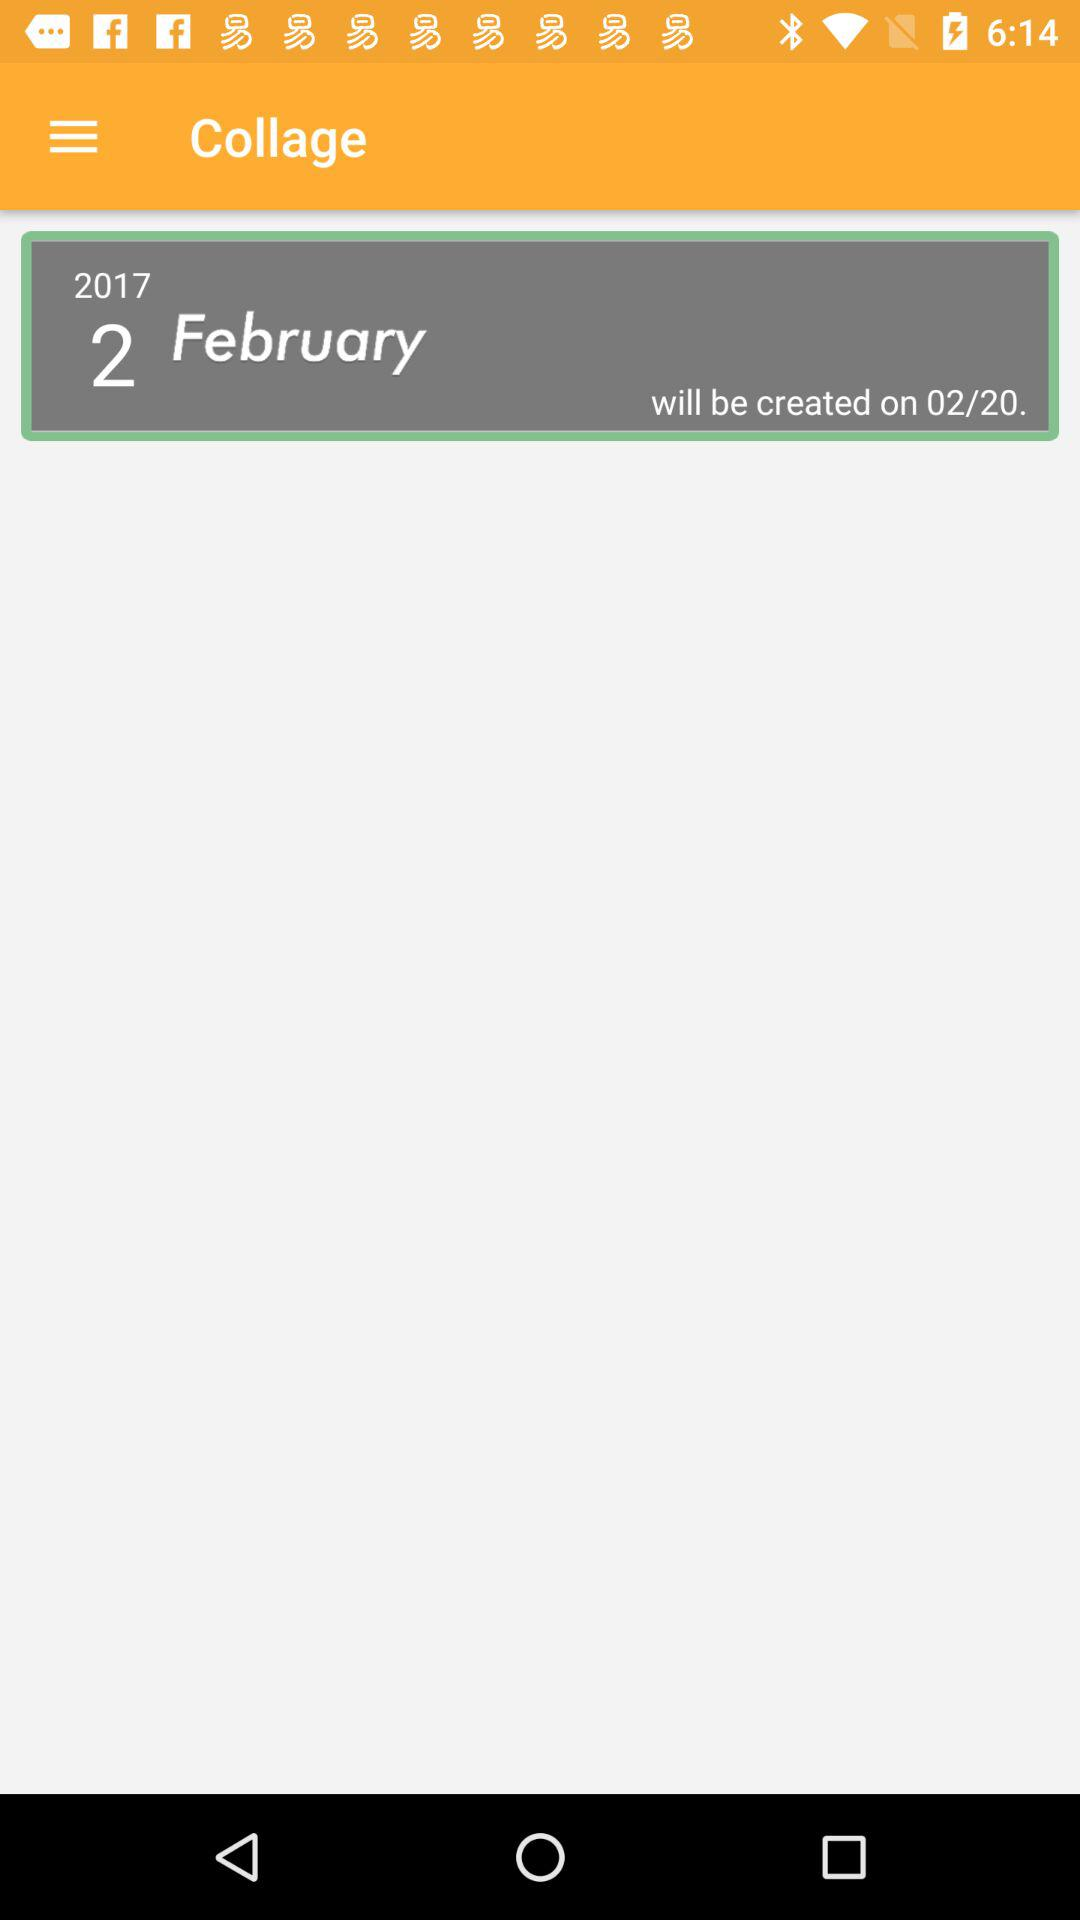What is the month of the date that will be created?
Answer the question using a single word or phrase. February 